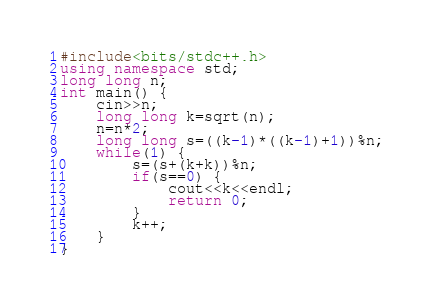Convert code to text. <code><loc_0><loc_0><loc_500><loc_500><_C++_>#include<bits/stdc++.h>
using namespace std;
long long n;
int main() {
	cin>>n;
	long long k=sqrt(n);
	n=n*2;
    long long s=((k-1)*((k-1)+1))%n;
	while(1) {	
		s=(s+(k+k))%n;
		if(s==0) {
			cout<<k<<endl;
			return 0;
		}
        k++;
	}
}</code> 